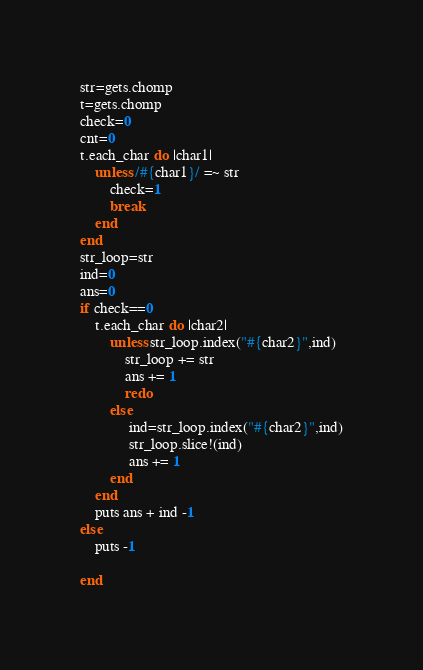Convert code to text. <code><loc_0><loc_0><loc_500><loc_500><_Ruby_>str=gets.chomp
t=gets.chomp
check=0
cnt=0
t.each_char do |char1|
    unless /#{char1}/ =~ str
        check=1
        break
    end
end
str_loop=str
ind=0
ans=0
if check==0
    t.each_char do |char2|
        unless str_loop.index("#{char2}",ind)
            str_loop += str
            ans += 1
            redo
        else
             ind=str_loop.index("#{char2}",ind)
             str_loop.slice!(ind)
             ans += 1
        end
    end
    puts ans + ind -1
else
    puts -1

end


</code> 